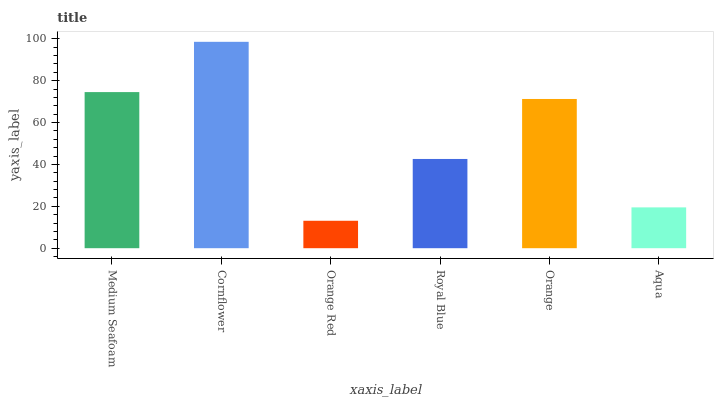Is Orange Red the minimum?
Answer yes or no. Yes. Is Cornflower the maximum?
Answer yes or no. Yes. Is Cornflower the minimum?
Answer yes or no. No. Is Orange Red the maximum?
Answer yes or no. No. Is Cornflower greater than Orange Red?
Answer yes or no. Yes. Is Orange Red less than Cornflower?
Answer yes or no. Yes. Is Orange Red greater than Cornflower?
Answer yes or no. No. Is Cornflower less than Orange Red?
Answer yes or no. No. Is Orange the high median?
Answer yes or no. Yes. Is Royal Blue the low median?
Answer yes or no. Yes. Is Cornflower the high median?
Answer yes or no. No. Is Medium Seafoam the low median?
Answer yes or no. No. 